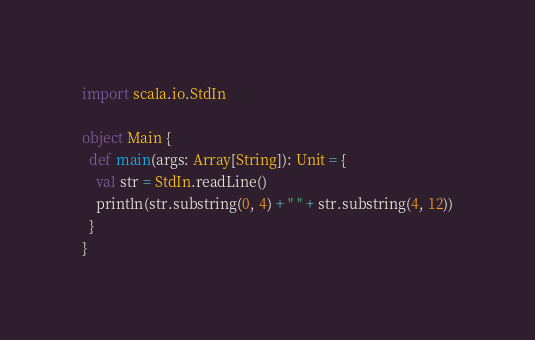Convert code to text. <code><loc_0><loc_0><loc_500><loc_500><_Scala_>

import scala.io.StdIn

object Main {
  def main(args: Array[String]): Unit = {
    val str = StdIn.readLine()
    println(str.substring(0, 4) + " " + str.substring(4, 12))
  }
}
</code> 